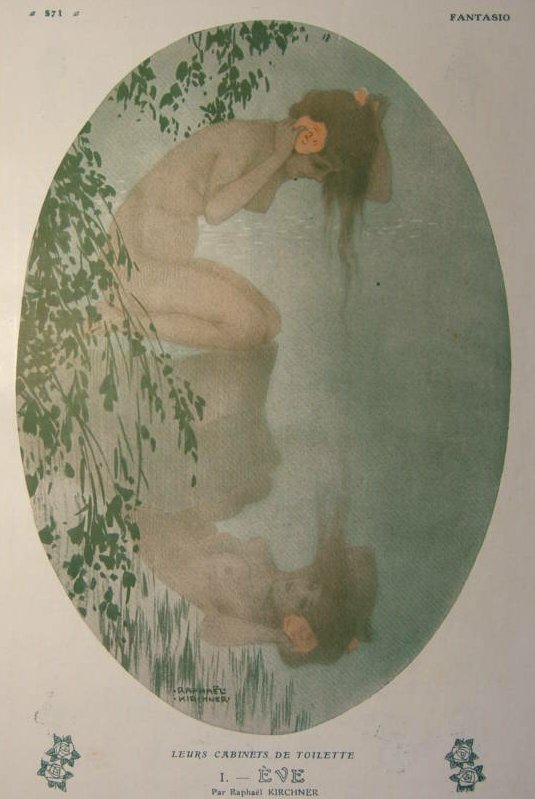Create a story inspired by this image. In a mystical forest shrouded in emerald green, amidst the whispering leaves and the gentle ripple of a crystal-clear pond, lived Elyra, a nymph with a heart as pure as the water she dwelled by. Elyra often found solace in the quiet embrace of her sanctuary, surrounded by the vibrant flora that seemed to sway in rhythm with her thoughts. One peaceful morning, while the dawn's light gently caressed the earth, Elyra discovered a rare pink blossom floating gracefully on the pond's surface. Intrigued, she delicately picked the flower, holding it close to her heart as she felt an inexplicable connection to this unexpected gift. What happens next in Elyra's story? Unbeknownst to Elyra, the pink blossom was enchanted, a token of affection from the Prince of the nearby hidden kingdom, who had long admired Elyra from afar. Feeling that it was time to reveal himself, the Prince approached the nymph's haven. As he stepped into the light, the enchantment of the flower began to unfold, casting a radiant glow around them. The Prince, bowing with grace, expressed his admiration and love for Elyra. Touched by his sincerity, Elyra felt her heart flutter with a warmth she had never known. Thus began a profound bond between the nymph and the Prince, one that blossomed into a tale of unity, love, and the harmonious blending of two worlds. 